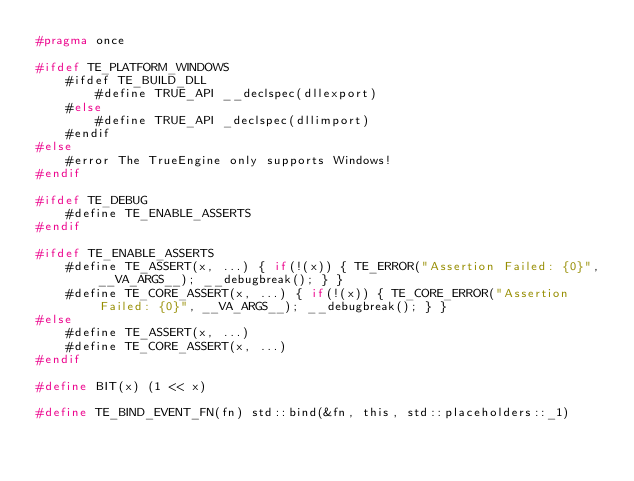Convert code to text. <code><loc_0><loc_0><loc_500><loc_500><_C_>#pragma once

#ifdef TE_PLATFORM_WINDOWS
	#ifdef TE_BUILD_DLL
		#define TRUE_API __declspec(dllexport)
	#else
		#define TRUE_API _declspec(dllimport)
	#endif
#else
	#error The TrueEngine only supports Windows!
#endif

#ifdef TE_DEBUG
	#define TE_ENABLE_ASSERTS
#endif

#ifdef TE_ENABLE_ASSERTS
	#define TE_ASSERT(x, ...) { if(!(x)) { TE_ERROR("Assertion Failed: {0}", __VA_ARGS__); __debugbreak(); } }
	#define TE_CORE_ASSERT(x, ...) { if(!(x)) { TE_CORE_ERROR("Assertion Failed: {0}", __VA_ARGS__); __debugbreak(); } }
#else
	#define TE_ASSERT(x, ...)
	#define TE_CORE_ASSERT(x, ...)
#endif

#define BIT(x) (1 << x)

#define TE_BIND_EVENT_FN(fn) std::bind(&fn, this, std::placeholders::_1)</code> 